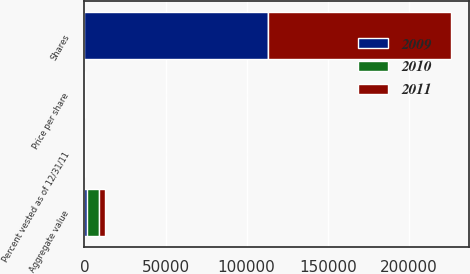<chart> <loc_0><loc_0><loc_500><loc_500><stacked_bar_chart><ecel><fcel>Shares<fcel>Price per share<fcel>Aggregate value<fcel>Percent vested as of 12/31/11<nl><fcel>2010<fcel>44.39<fcel>44.39<fcel>7424<fcel>0<nl><fcel>2011<fcel>112500<fcel>30.87<fcel>3473<fcel>20<nl><fcel>2009<fcel>113250<fcel>15.67<fcel>1774<fcel>40<nl></chart> 